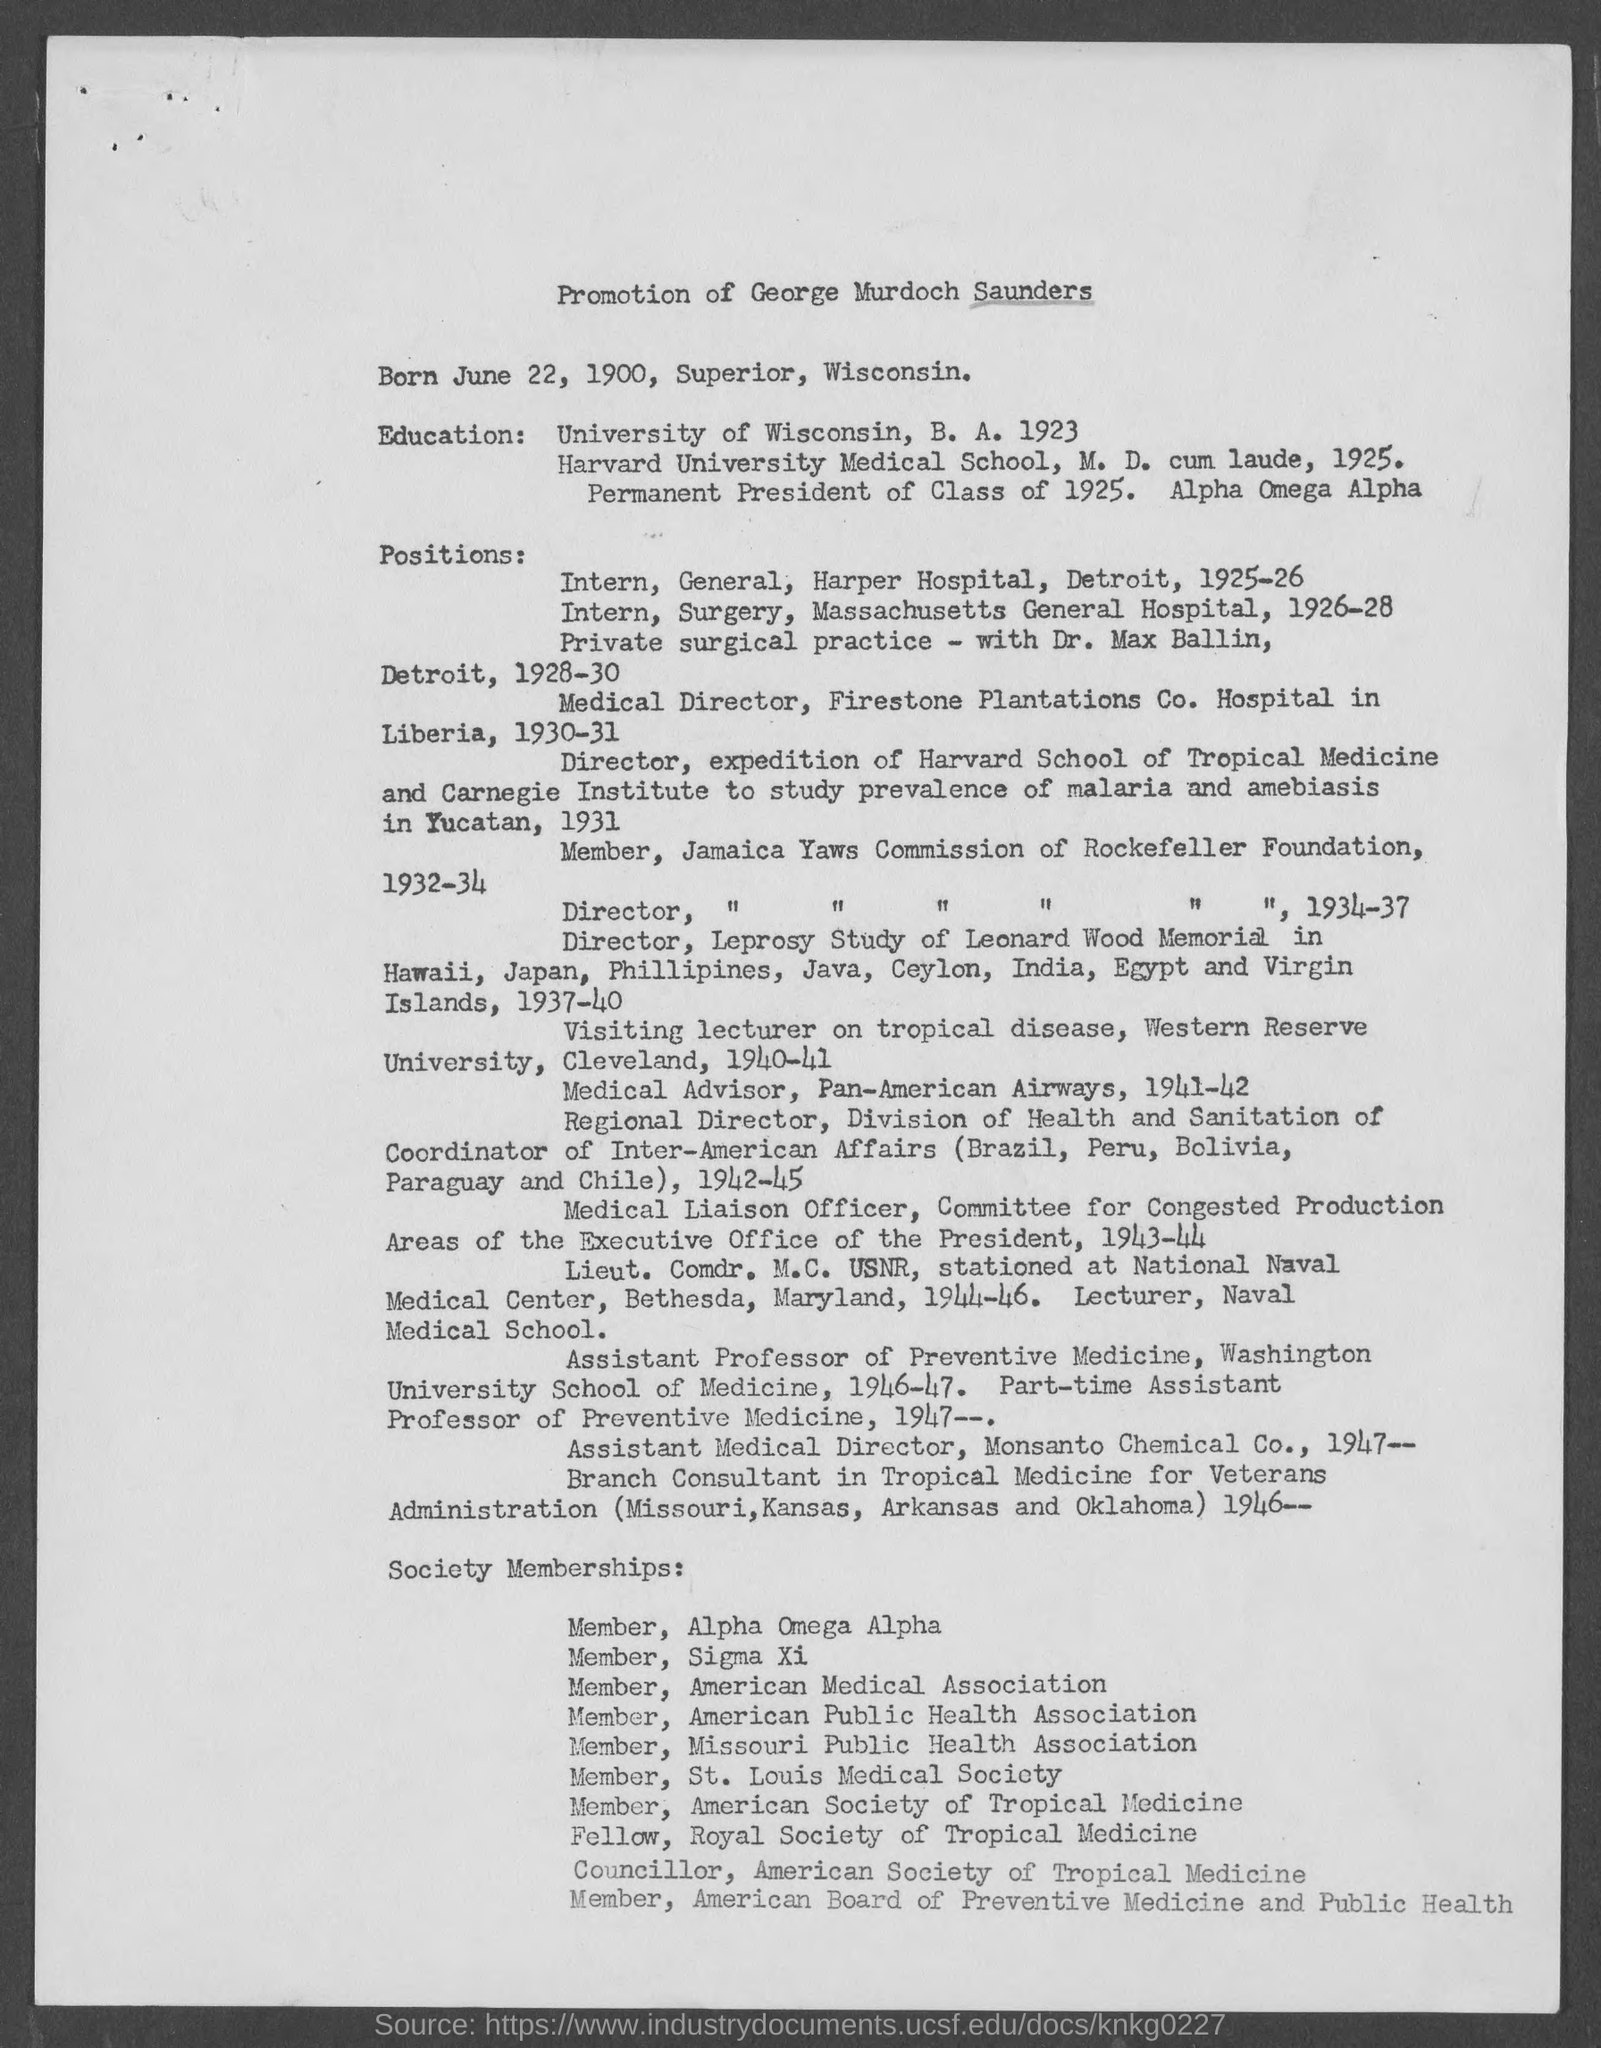What is the candidate name for promotion ?
Provide a short and direct response. George Murdoch Saunders. What is the date of birth of george murdoch saunders ?
Keep it short and to the point. June 22, 1900. What is the place of birth of george murdoch saunders ?
Give a very brief answer. Superior, Wisconsin. 